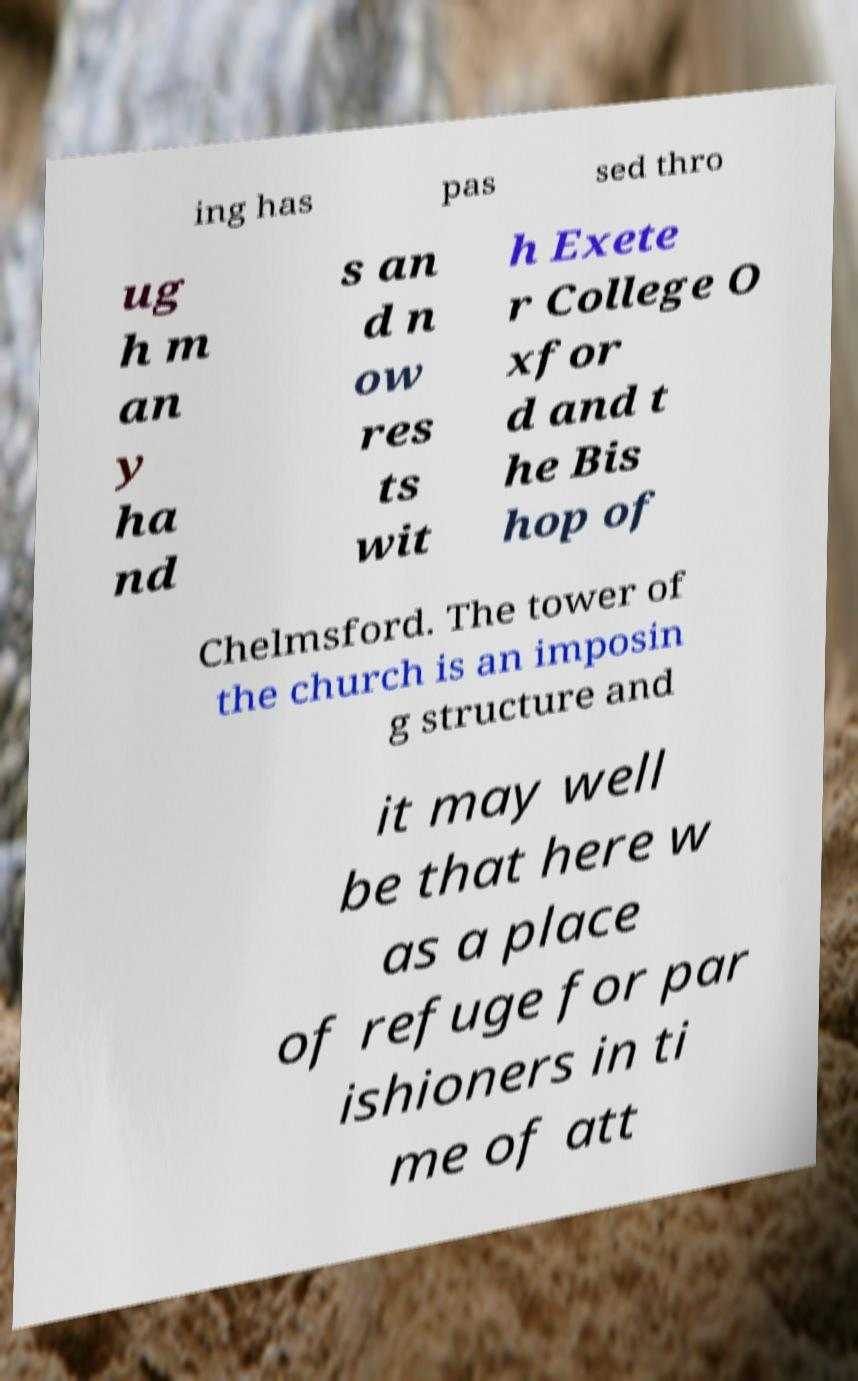Can you accurately transcribe the text from the provided image for me? ing has pas sed thro ug h m an y ha nd s an d n ow res ts wit h Exete r College O xfor d and t he Bis hop of Chelmsford. The tower of the church is an imposin g structure and it may well be that here w as a place of refuge for par ishioners in ti me of att 